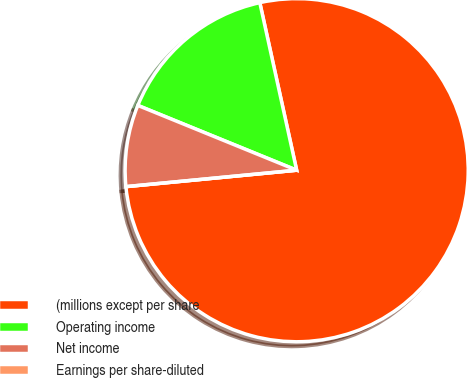Convert chart to OTSL. <chart><loc_0><loc_0><loc_500><loc_500><pie_chart><fcel>(millions except per share<fcel>Operating income<fcel>Net income<fcel>Earnings per share-diluted<nl><fcel>76.92%<fcel>15.39%<fcel>7.69%<fcel>0.0%<nl></chart> 